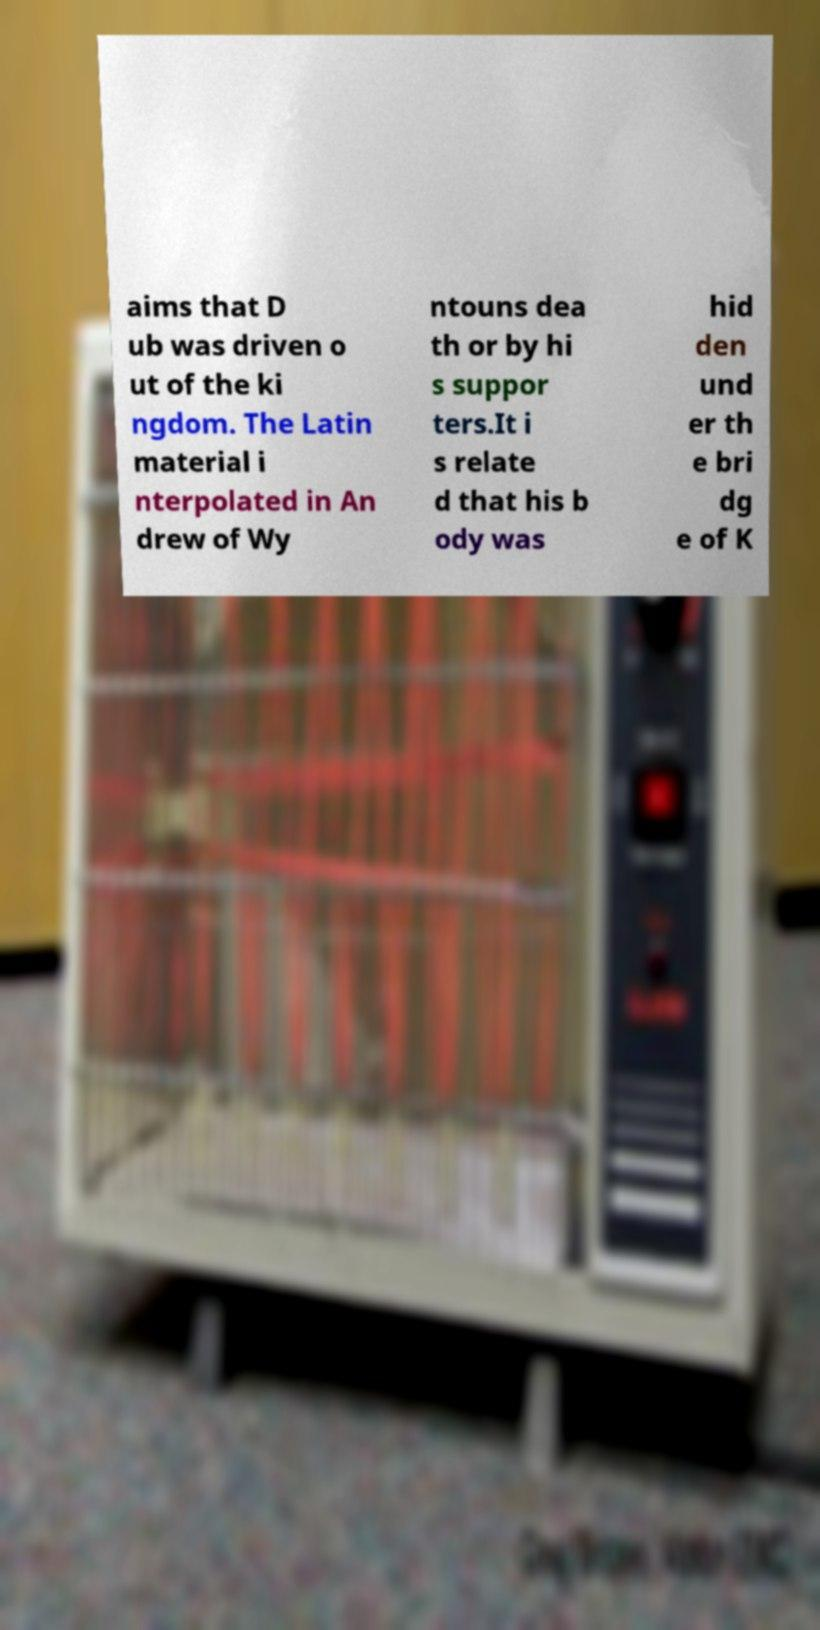Could you extract and type out the text from this image? aims that D ub was driven o ut of the ki ngdom. The Latin material i nterpolated in An drew of Wy ntouns dea th or by hi s suppor ters.It i s relate d that his b ody was hid den und er th e bri dg e of K 